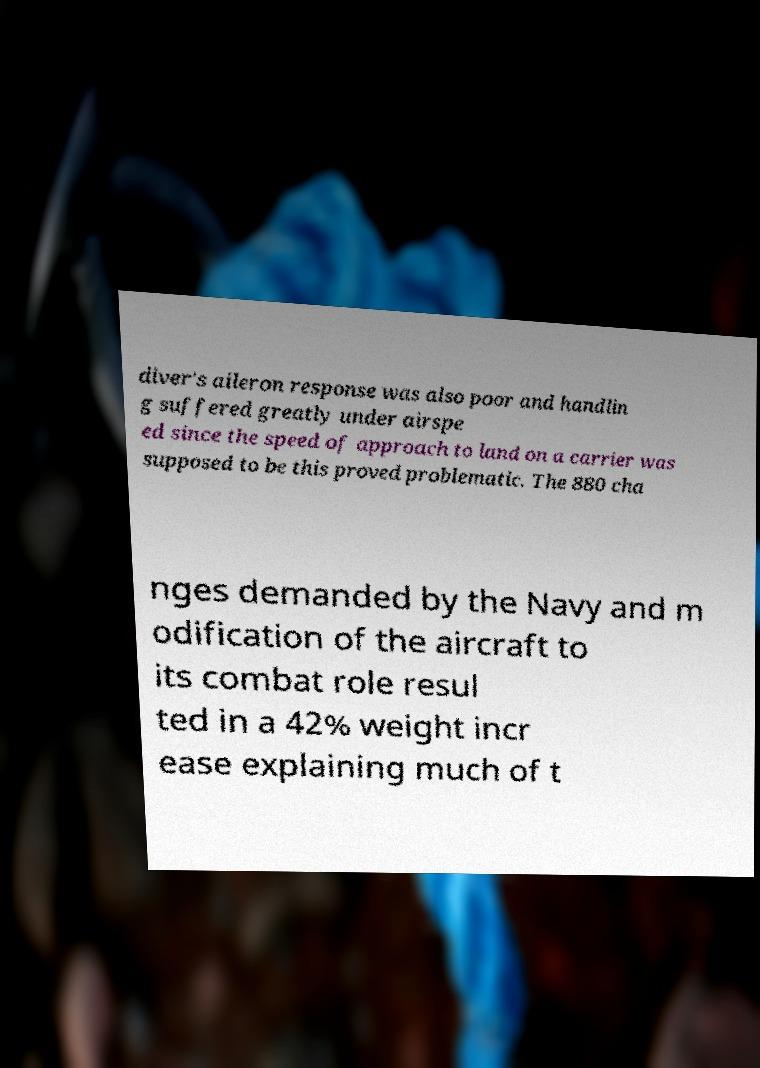I need the written content from this picture converted into text. Can you do that? diver's aileron response was also poor and handlin g suffered greatly under airspe ed since the speed of approach to land on a carrier was supposed to be this proved problematic. The 880 cha nges demanded by the Navy and m odification of the aircraft to its combat role resul ted in a 42% weight incr ease explaining much of t 